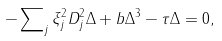<formula> <loc_0><loc_0><loc_500><loc_500>- \sum \nolimits _ { j } \xi _ { j } ^ { 2 } D _ { j } ^ { 2 } \Delta + b \Delta ^ { 3 } - \tau \Delta = 0 ,</formula> 